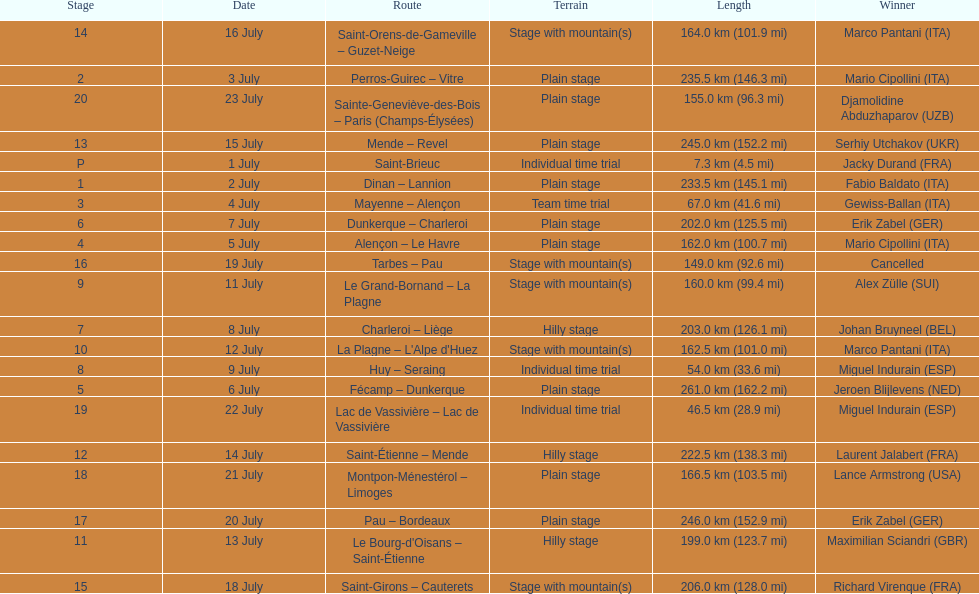How much longer is the 20th tour de france stage than the 19th? 108.5 km. 